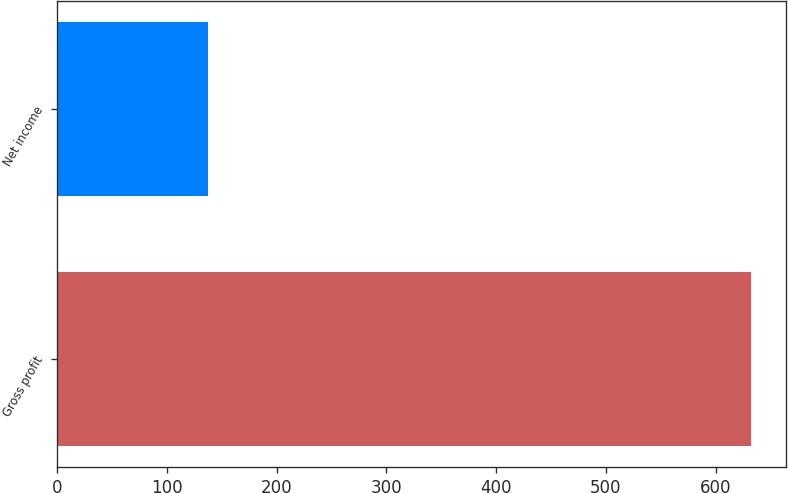<chart> <loc_0><loc_0><loc_500><loc_500><bar_chart><fcel>Gross profit<fcel>Net income<nl><fcel>632.6<fcel>137<nl></chart> 